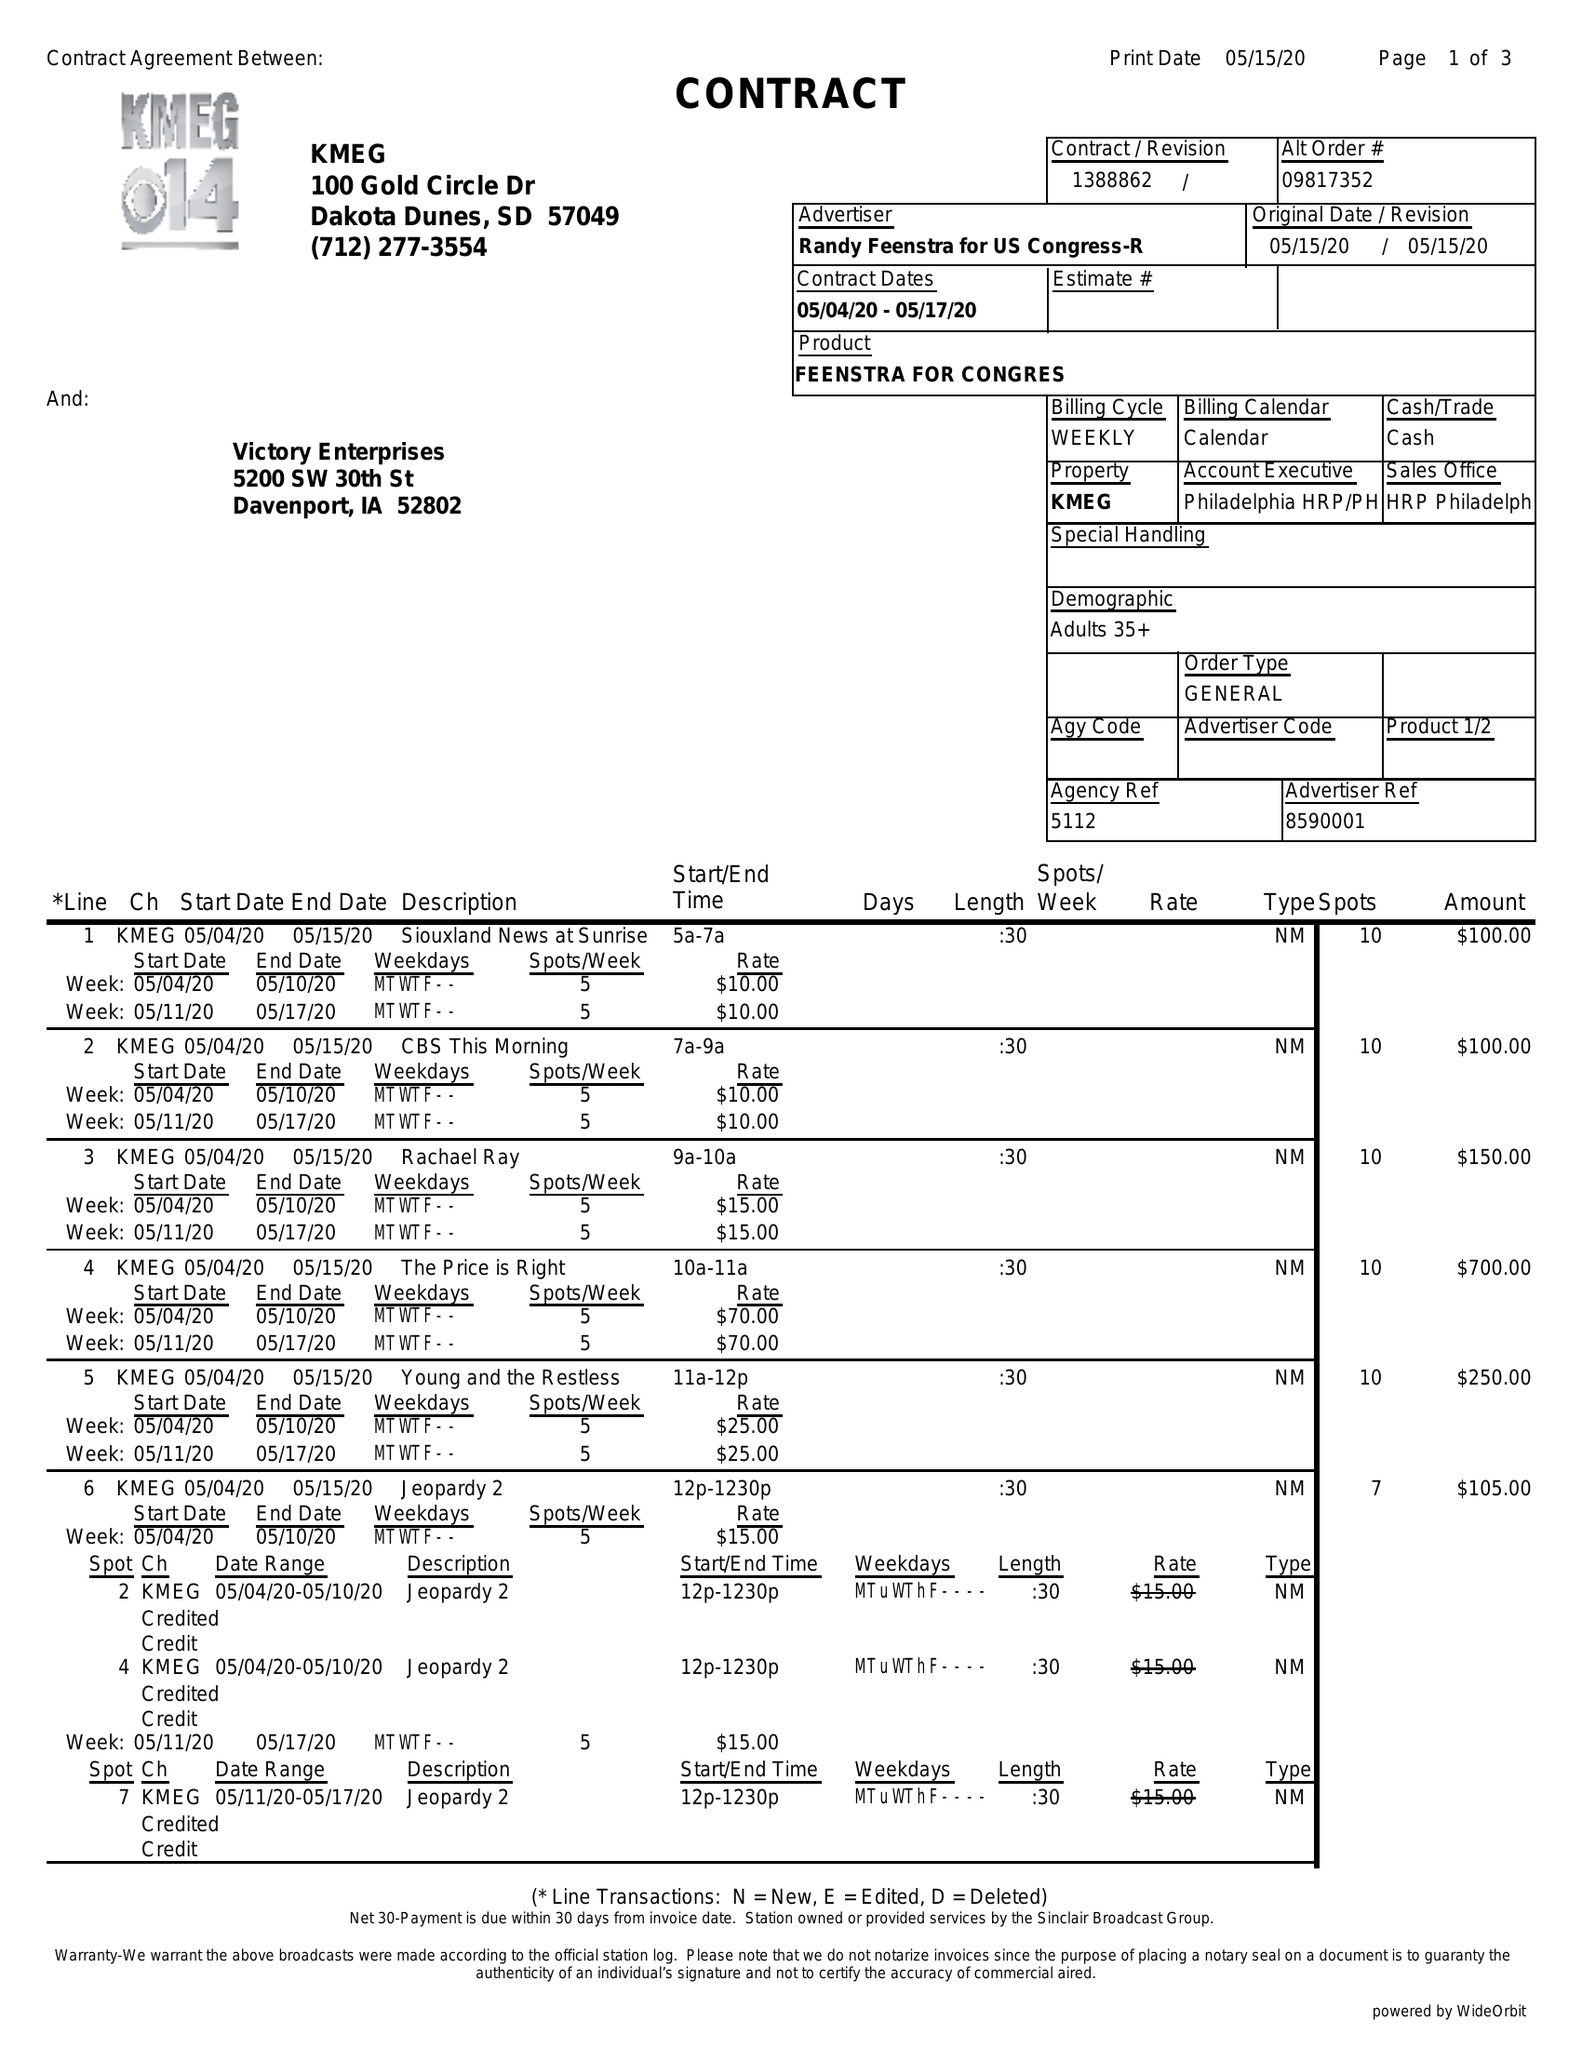What is the value for the gross_amount?
Answer the question using a single word or phrase. 6440.00 